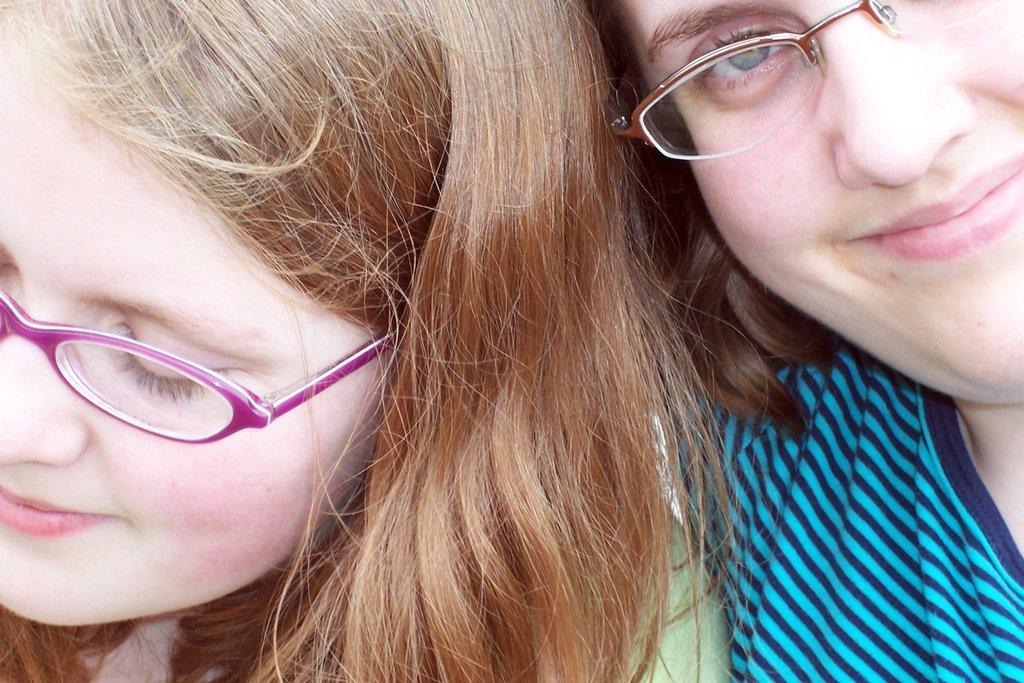How many girls are in the image? There are two girls in the image. What is the girl on the right wearing? The girl on the right is wearing a blue T-shirt. What accessory do both girls have in common? Both girls are wearing glasses. What type of cork can be seen on the girls' shoes in the image? There is no cork visible on the girls' shoes in the image. How many cars are parked behind the girls in the image? There are no cars present in the image. 